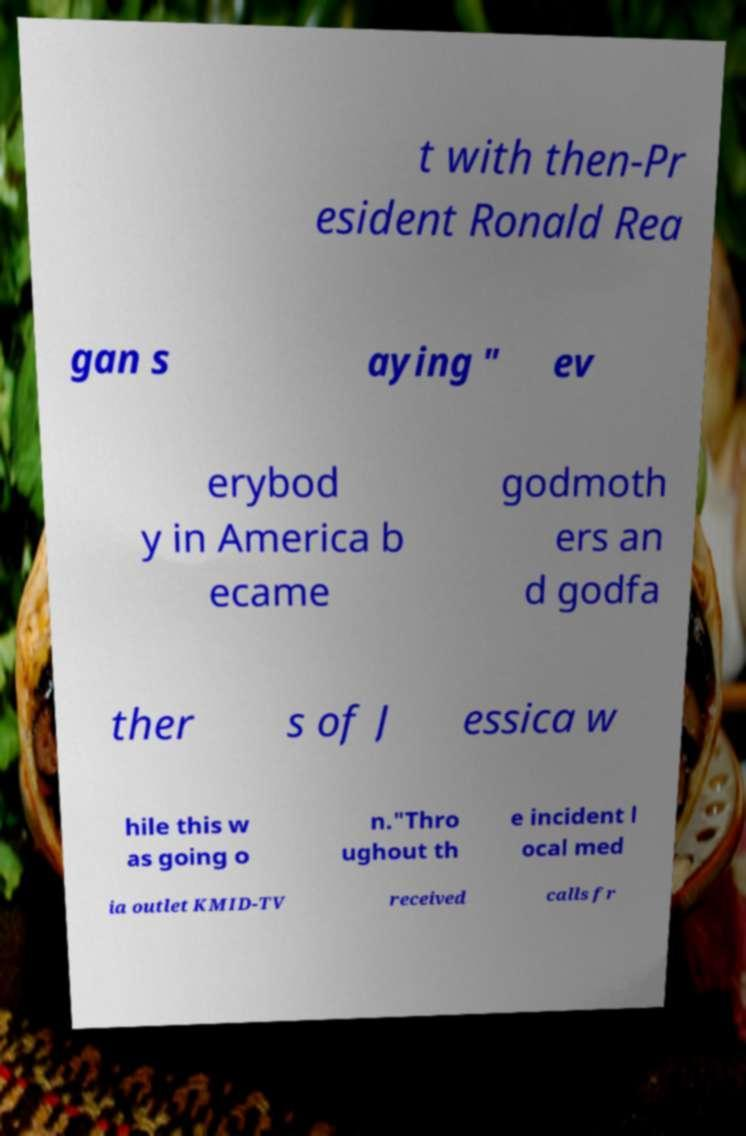Could you assist in decoding the text presented in this image and type it out clearly? t with then-Pr esident Ronald Rea gan s aying " ev erybod y in America b ecame godmoth ers an d godfa ther s of J essica w hile this w as going o n."Thro ughout th e incident l ocal med ia outlet KMID-TV received calls fr 